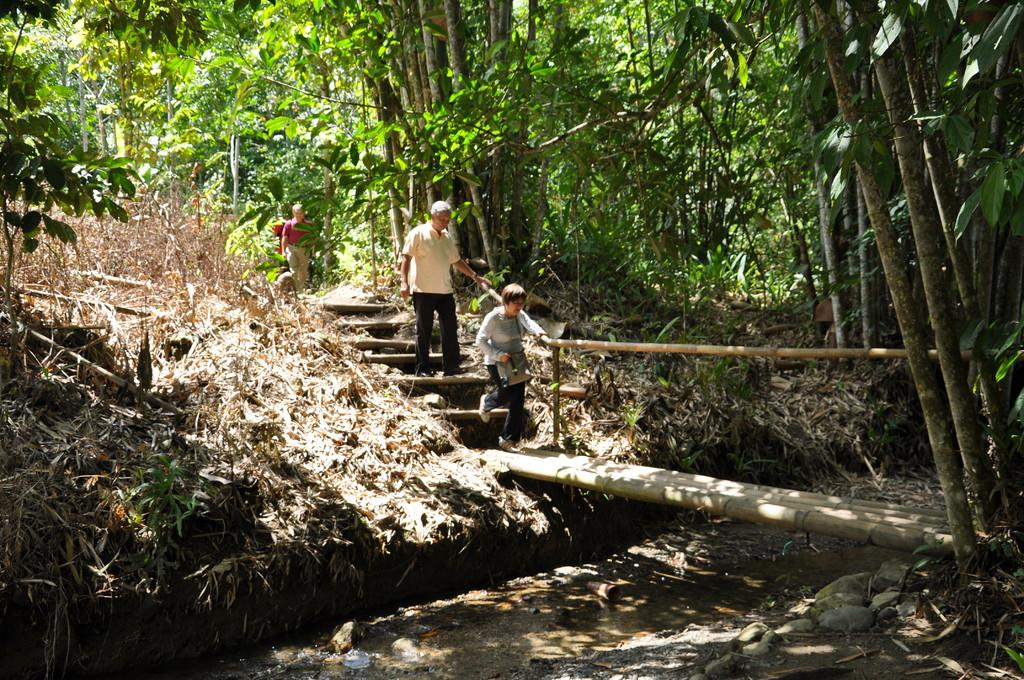What is the main focus of the image? There are people in the center of the image. What architectural feature can be seen in the image? There are stairs in the image. What is located at the bottom of the image? There is a bridge at the bottom of the image. What type of vegetation is visible in the background of the image? There are trees and grass visible in the background of the image. What type of throat condition can be seen in the image? There is no throat condition present in the image. What scene is depicted in the image? The image depicts people, stairs, a bridge, trees, and grass, as described in the conversation. 